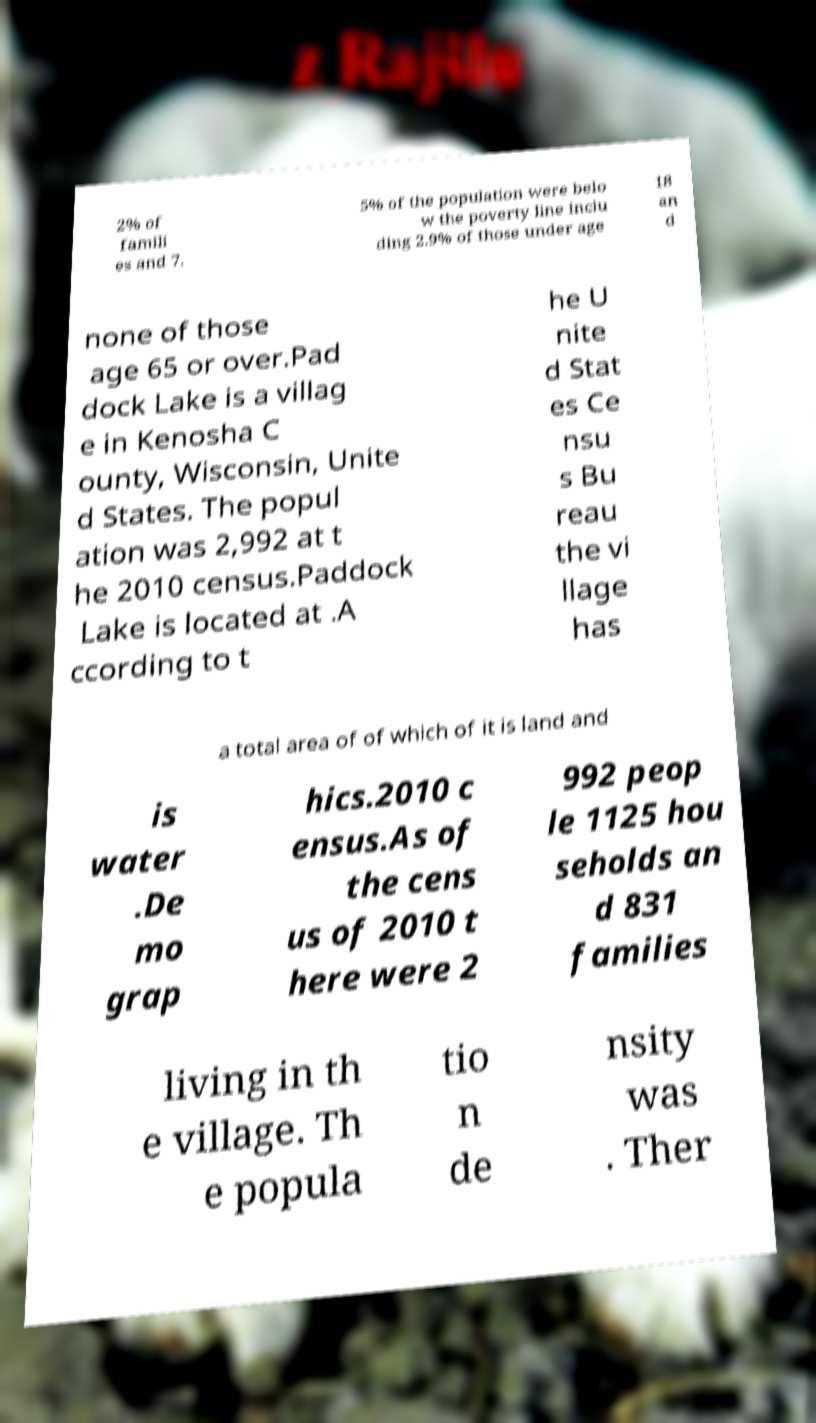Can you accurately transcribe the text from the provided image for me? 2% of famili es and 7. 5% of the population were belo w the poverty line inclu ding 2.9% of those under age 18 an d none of those age 65 or over.Pad dock Lake is a villag e in Kenosha C ounty, Wisconsin, Unite d States. The popul ation was 2,992 at t he 2010 census.Paddock Lake is located at .A ccording to t he U nite d Stat es Ce nsu s Bu reau the vi llage has a total area of of which of it is land and is water .De mo grap hics.2010 c ensus.As of the cens us of 2010 t here were 2 992 peop le 1125 hou seholds an d 831 families living in th e village. Th e popula tio n de nsity was . Ther 